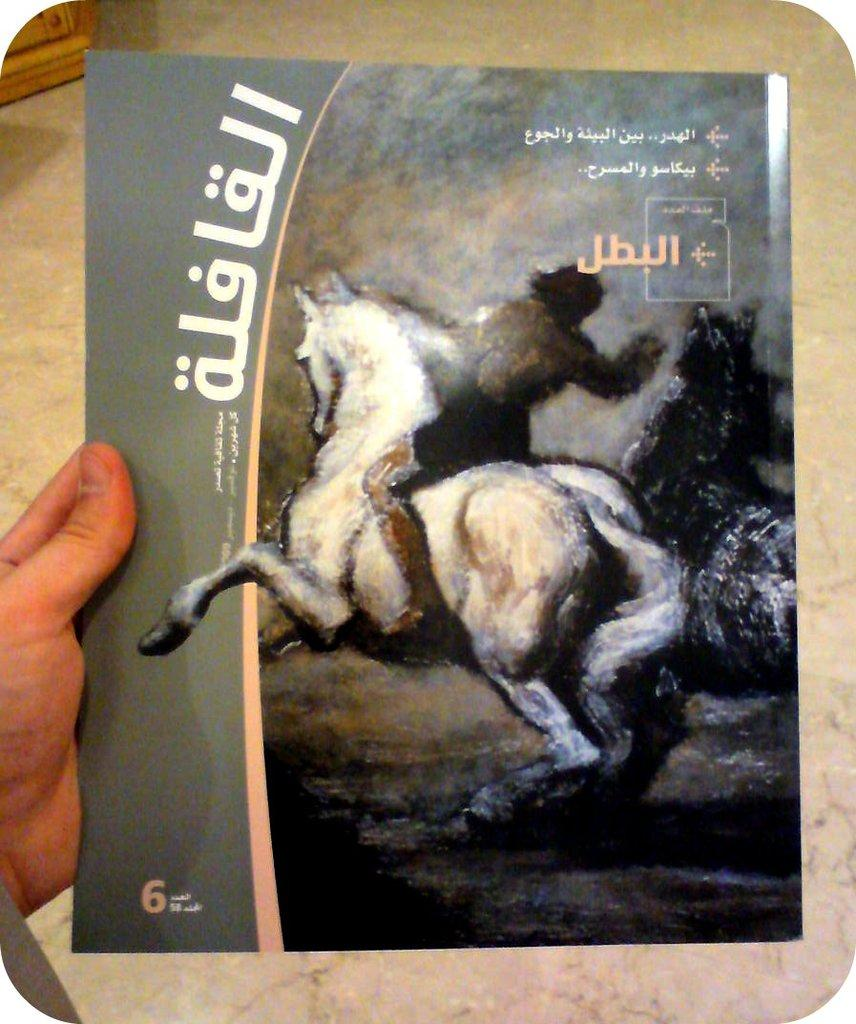<image>
Describe the image concisely. A cover with a picture of a man on a horse, writing in Arabic, and the number 6 on it. 